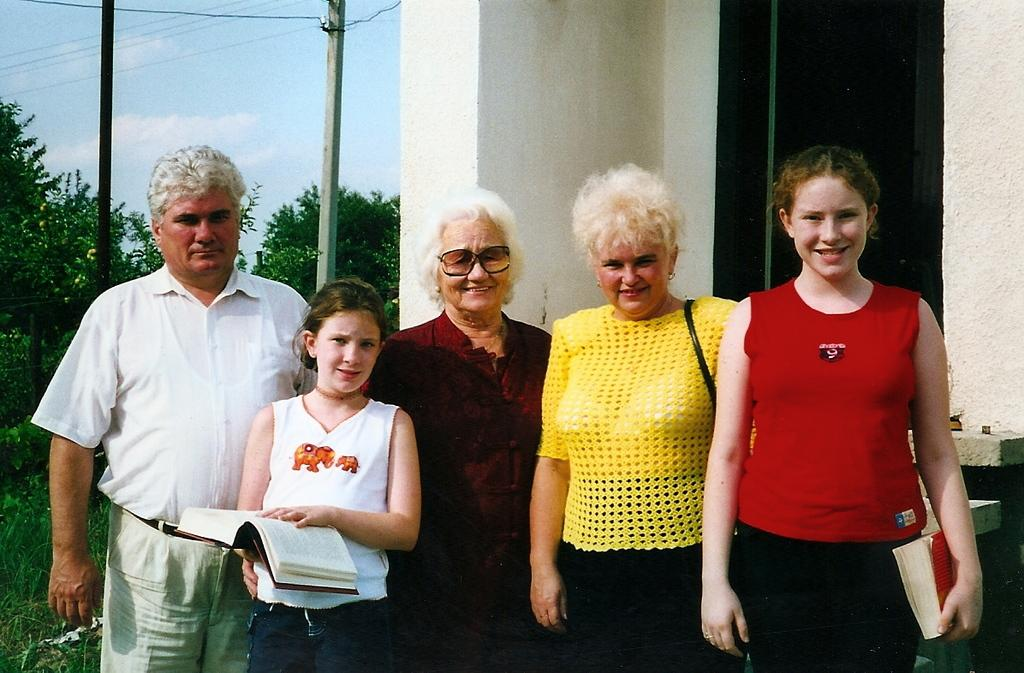What is happening in the image? There are people standing in the image. What can be seen in the background of the image? There is a house, poles, trees, and the sky visible in the background of the image. How much glue is needed to stick the crook to the distance in the image? There is no crook or distance present in the image, and therefore no need for glue. 